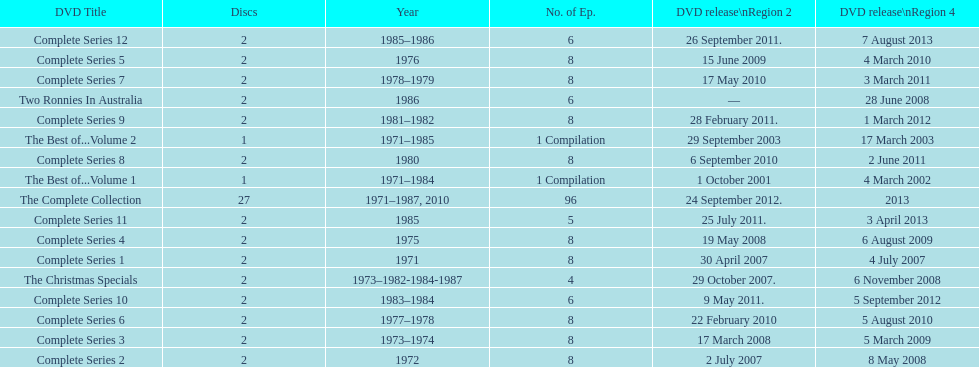How many "best of" volumes compile the top episodes of the television show "the two ronnies". 2. 